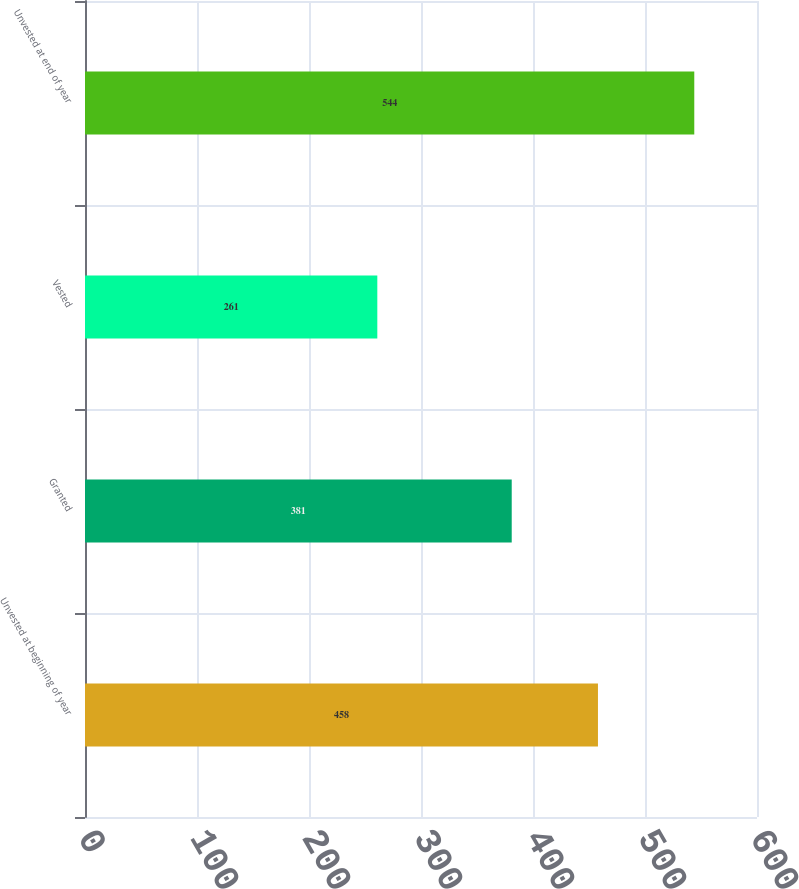Convert chart. <chart><loc_0><loc_0><loc_500><loc_500><bar_chart><fcel>Unvested at beginning of year<fcel>Granted<fcel>Vested<fcel>Unvested at end of year<nl><fcel>458<fcel>381<fcel>261<fcel>544<nl></chart> 